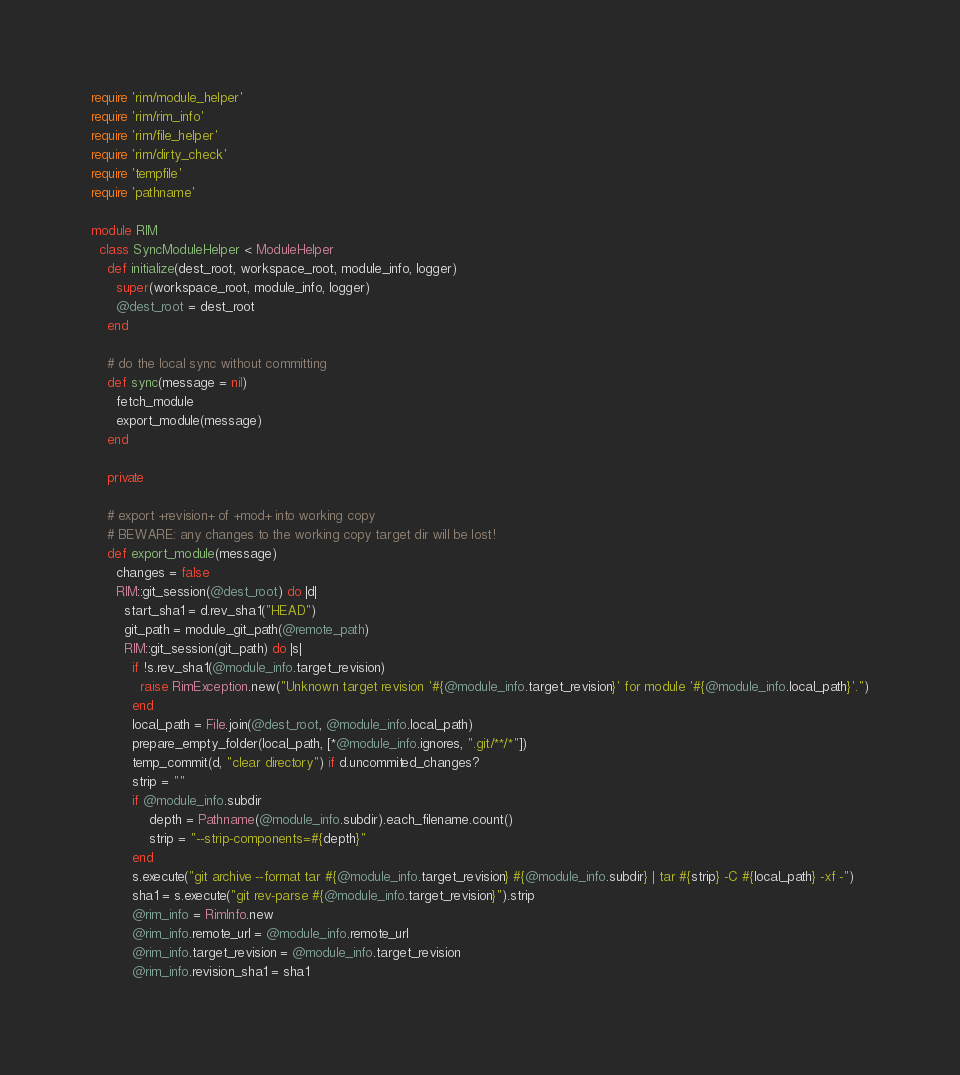Convert code to text. <code><loc_0><loc_0><loc_500><loc_500><_Ruby_>require 'rim/module_helper'
require 'rim/rim_info'
require 'rim/file_helper'
require 'rim/dirty_check'
require 'tempfile'
require 'pathname'

module RIM
  class SyncModuleHelper < ModuleHelper
    def initialize(dest_root, workspace_root, module_info, logger)
      super(workspace_root, module_info, logger)
      @dest_root = dest_root
    end

    # do the local sync without committing
    def sync(message = nil)
      fetch_module
      export_module(message)
    end

    private

    # export +revision+ of +mod+ into working copy
    # BEWARE: any changes to the working copy target dir will be lost!
    def export_module(message)
      changes = false
      RIM::git_session(@dest_root) do |d|
        start_sha1 = d.rev_sha1("HEAD")
        git_path = module_git_path(@remote_path)
        RIM::git_session(git_path) do |s|
          if !s.rev_sha1(@module_info.target_revision)
            raise RimException.new("Unknown target revision '#{@module_info.target_revision}' for module '#{@module_info.local_path}'.")
          end
          local_path = File.join(@dest_root, @module_info.local_path)
          prepare_empty_folder(local_path, [*@module_info.ignores, ".git/**/*"])
          temp_commit(d, "clear directory") if d.uncommited_changes?
          strip = ""
          if @module_info.subdir
              depth = Pathname(@module_info.subdir).each_filename.count()
              strip = "--strip-components=#{depth}"
          end
          s.execute("git archive --format tar #{@module_info.target_revision} #{@module_info.subdir} | tar #{strip} -C #{local_path} -xf -")
          sha1 = s.execute("git rev-parse #{@module_info.target_revision}").strip
          @rim_info = RimInfo.new
          @rim_info.remote_url = @module_info.remote_url
          @rim_info.target_revision = @module_info.target_revision
          @rim_info.revision_sha1 = sha1</code> 